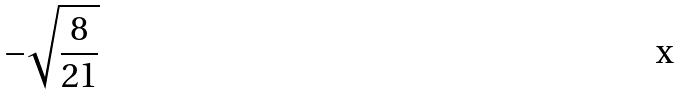<formula> <loc_0><loc_0><loc_500><loc_500>- \sqrt { \frac { 8 } { 2 1 } }</formula> 